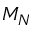Convert formula to latex. <formula><loc_0><loc_0><loc_500><loc_500>M _ { N }</formula> 